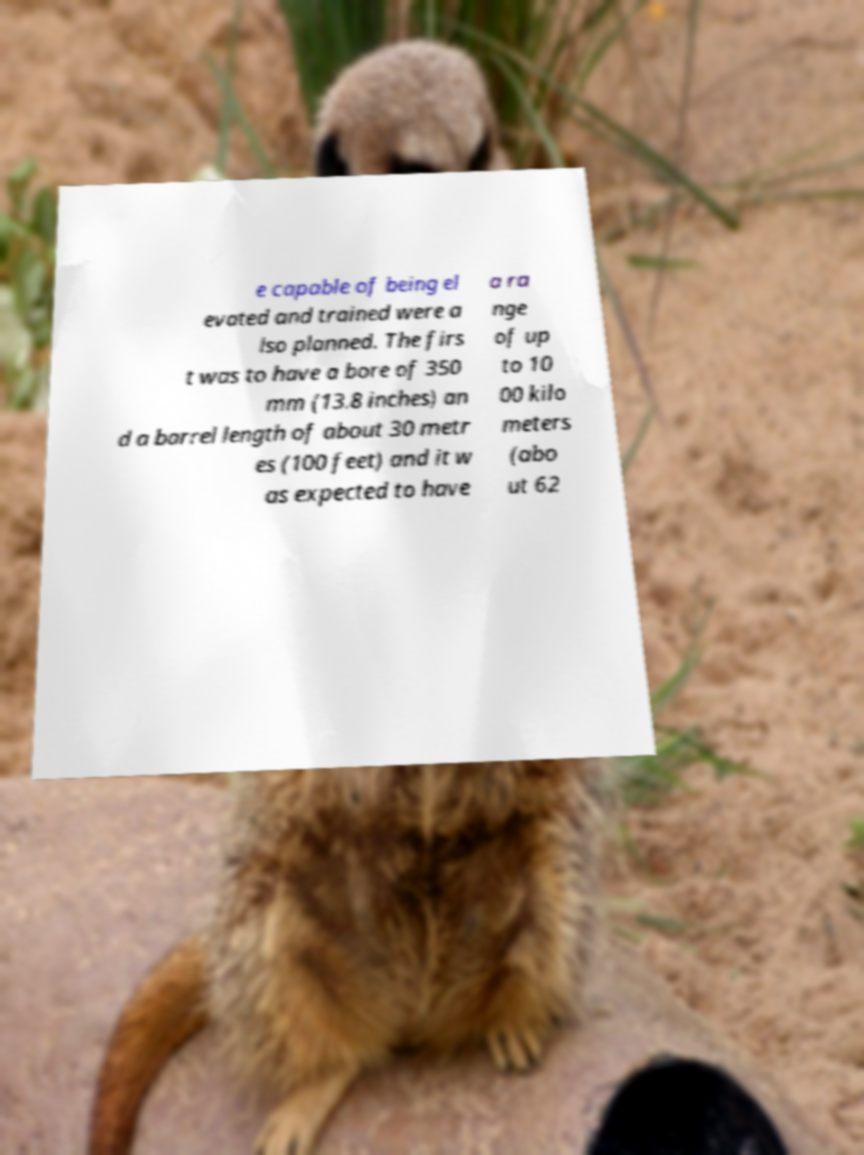I need the written content from this picture converted into text. Can you do that? e capable of being el evated and trained were a lso planned. The firs t was to have a bore of 350 mm (13.8 inches) an d a barrel length of about 30 metr es (100 feet) and it w as expected to have a ra nge of up to 10 00 kilo meters (abo ut 62 